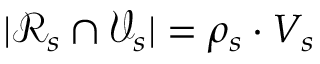<formula> <loc_0><loc_0><loc_500><loc_500>| \mathcal { R } _ { s } \cap \mathcal { V } _ { s } | = \rho _ { s } \cdot V _ { s }</formula> 